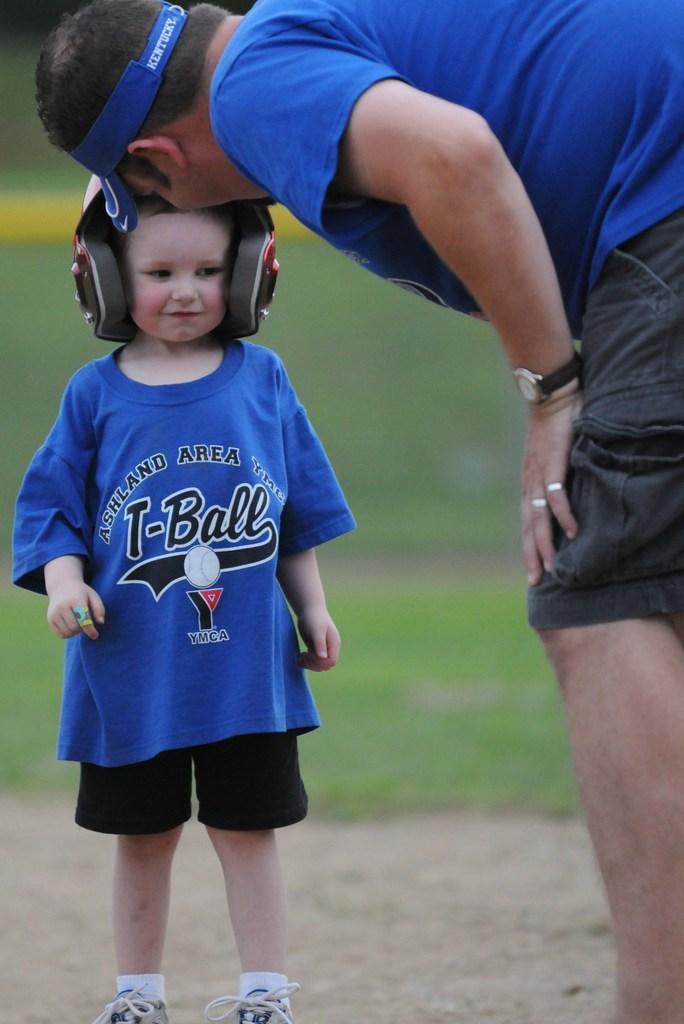Can you describe this image briefly? In this image I can see a child and a man, I can see both of them are wearing blue t shirt, black shorts and I can see he is wearing blue cap. I can see this child is wearing a helmet. In the background I can see green colour and I can see this image is little bit blurry from background. 